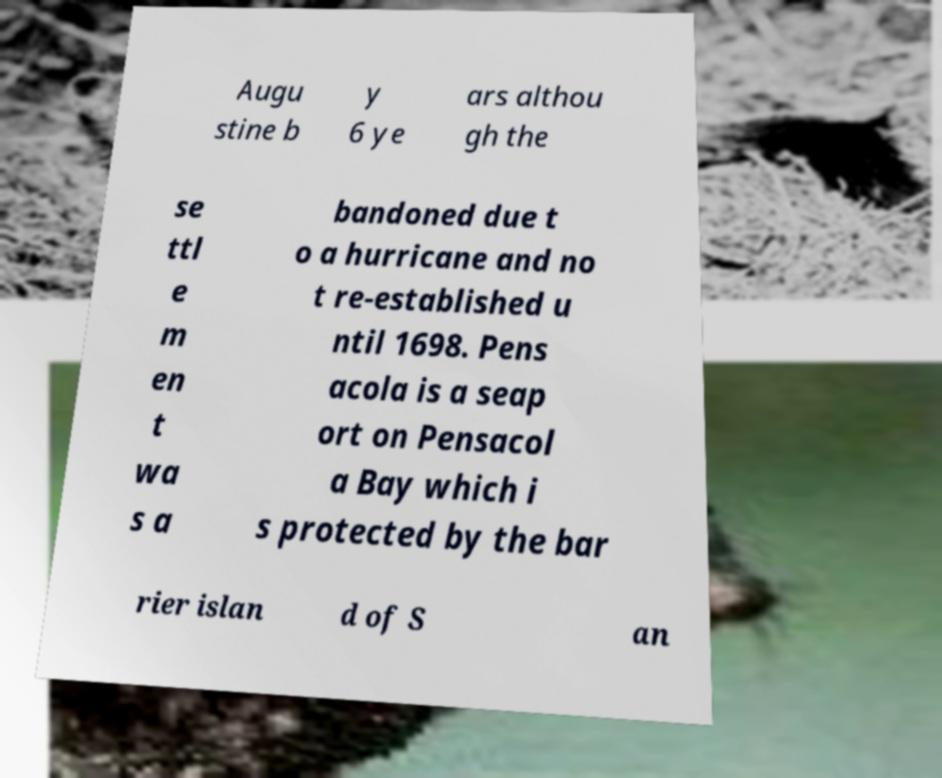There's text embedded in this image that I need extracted. Can you transcribe it verbatim? Augu stine b y 6 ye ars althou gh the se ttl e m en t wa s a bandoned due t o a hurricane and no t re-established u ntil 1698. Pens acola is a seap ort on Pensacol a Bay which i s protected by the bar rier islan d of S an 